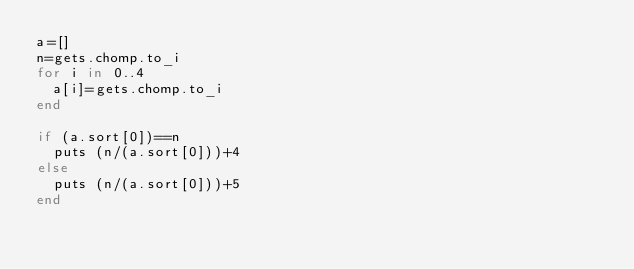<code> <loc_0><loc_0><loc_500><loc_500><_Ruby_>a=[]
n=gets.chomp.to_i
for i in 0..4
  a[i]=gets.chomp.to_i
end

if (a.sort[0])==n
  puts (n/(a.sort[0]))+4
else
  puts (n/(a.sort[0]))+5
end
</code> 